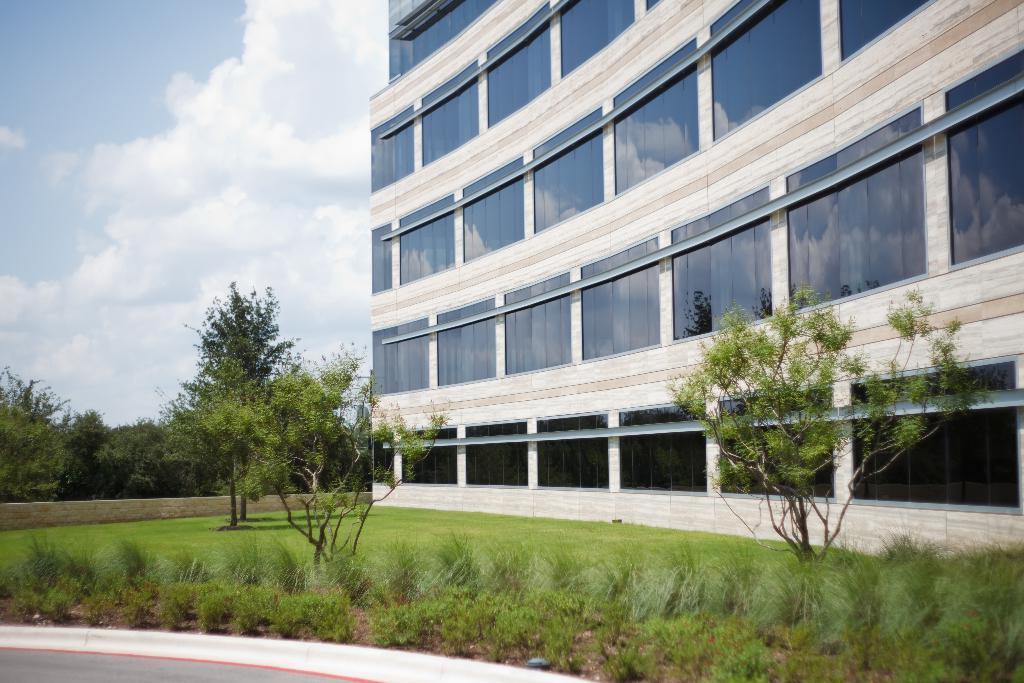Please provide a concise description of this image. In this image there is a building, there are trees, plants, grass and some clouds in the sky, there are reflections of trees and clouds in the windows of the building. 